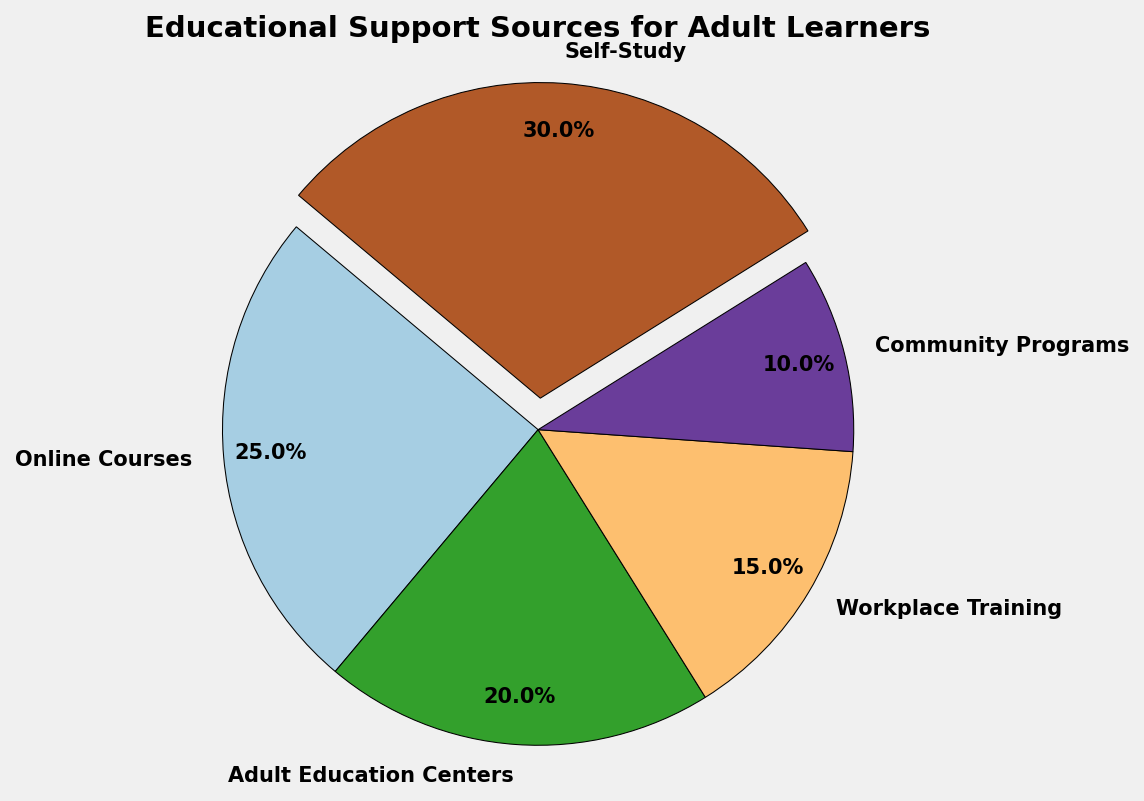What percentage of adult learners rely on self-study? The self-study segment in the pie chart is labeled as 30%.
Answer: 30% Which source of educational support has the lowest representation? The segment with 10% is the smallest, which corresponds to community programs.
Answer: Community Programs How much more popular is online courses compared to workplace training? Online courses have a percentage of 25% and workplace training has 15%. The difference is 25% - 15% = 10%.
Answer: 10% What is the combined percentage of adult education centers and community programs? Adult education centers account for 20% and community programs for 10%. Their combined percentage is 20% + 10% = 30%.
Answer: 30% Of the sources given, which two combined contribute to half of the educational support sources? Both self-study (30%) and adult education centers (20%) combine to 30% + 20% = 50%.
Answer: Self-Study and Adult Education Centers Which source of educational support is represented by the color that is most similar to blue in the chart? Since the given data didn't specify exact colors, we would visually identify the segment colored most similarly to blue, which will need referencing the actual chart. Typically, look for a segment medium-toned, darker, or lighter shade of blue.
Answer: (Depends on the Chart) What is the difference in percentage points between the largest and smallest sources of educational support? The largest source is self-study at 30% and the smallest is community programs at 10%. The difference is 30% - 10% = 20%.
Answer: 20% Are more adult learners utilizing adult education centers or workplace training? By comparing percentages, adult education centers have 20% and workplace training has 15%. Hence, more learners are utilizing adult education centers.
Answer: Adult Education Centers If you wanted to develop a new educational program, would you focus on increasing support for community programs if your goal was to balance all sources evenly? Why? Currently, community programs have the lowest percentage of all sources at 10%. Balancing all sources would require increasing the smallest segment to share more evenly with others.
Answer: Yes 